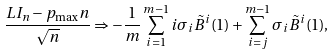Convert formula to latex. <formula><loc_0><loc_0><loc_500><loc_500>\frac { L I _ { n } - p _ { \max } n } { \sqrt { n } } \Rightarrow - \frac { 1 } { m } \sum ^ { m - 1 } _ { i = 1 } i \sigma _ { i } \tilde { B } ^ { i } ( 1 ) + \sum ^ { m - 1 } _ { i = j } \sigma _ { i } \tilde { B } ^ { i } ( 1 ) ,</formula> 